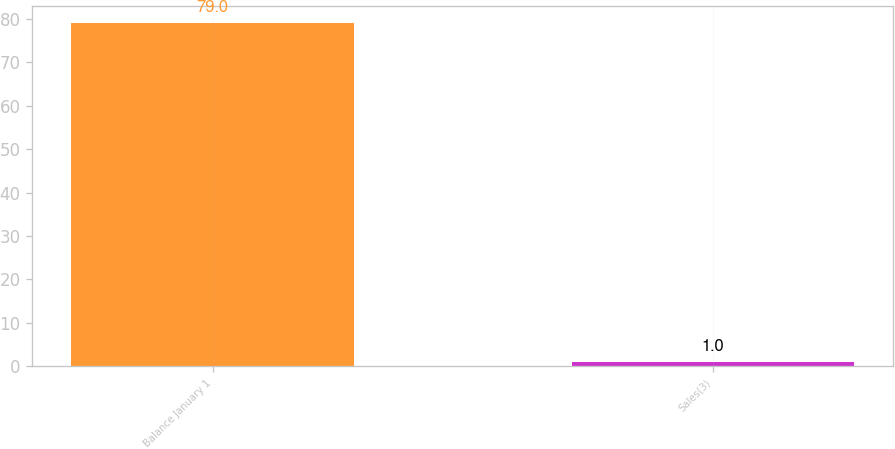<chart> <loc_0><loc_0><loc_500><loc_500><bar_chart><fcel>Balance January 1<fcel>Sales(3)<nl><fcel>79<fcel>1<nl></chart> 